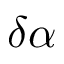<formula> <loc_0><loc_0><loc_500><loc_500>\delta \alpha</formula> 